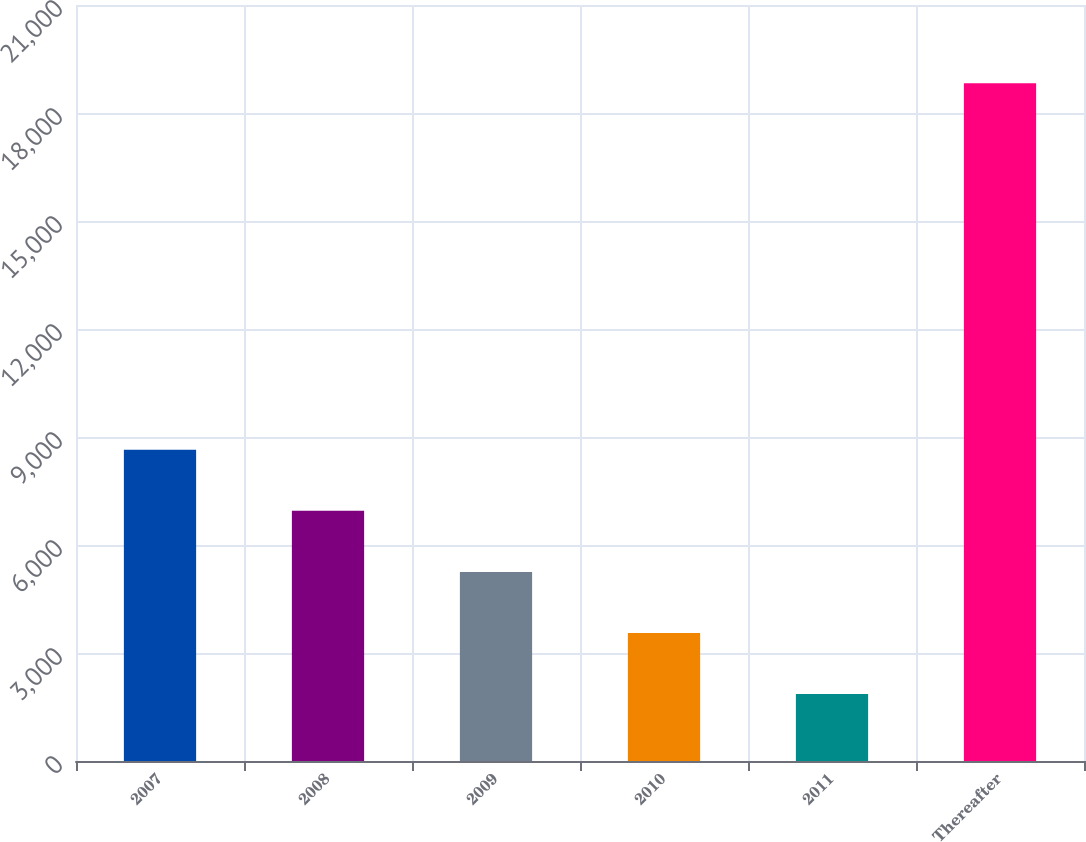Convert chart. <chart><loc_0><loc_0><loc_500><loc_500><bar_chart><fcel>2007<fcel>2008<fcel>2009<fcel>2010<fcel>2011<fcel>Thereafter<nl><fcel>8645<fcel>6948.5<fcel>5252<fcel>3555.5<fcel>1859<fcel>18824<nl></chart> 